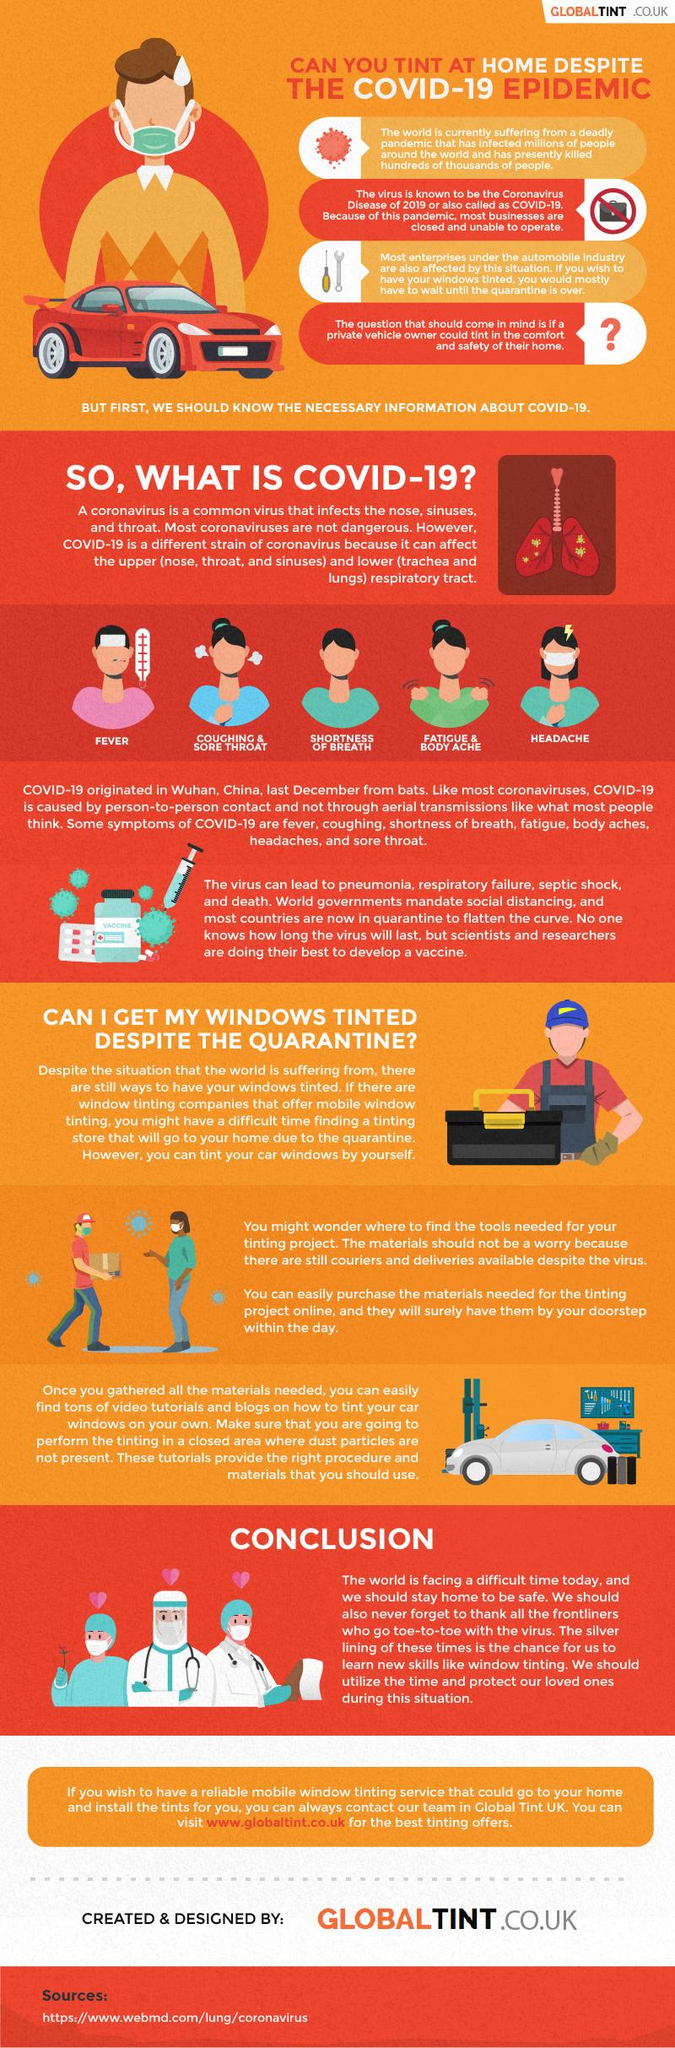Point out several critical features in this image. The first case of COVID-19 was reported in Wuhan, China. 